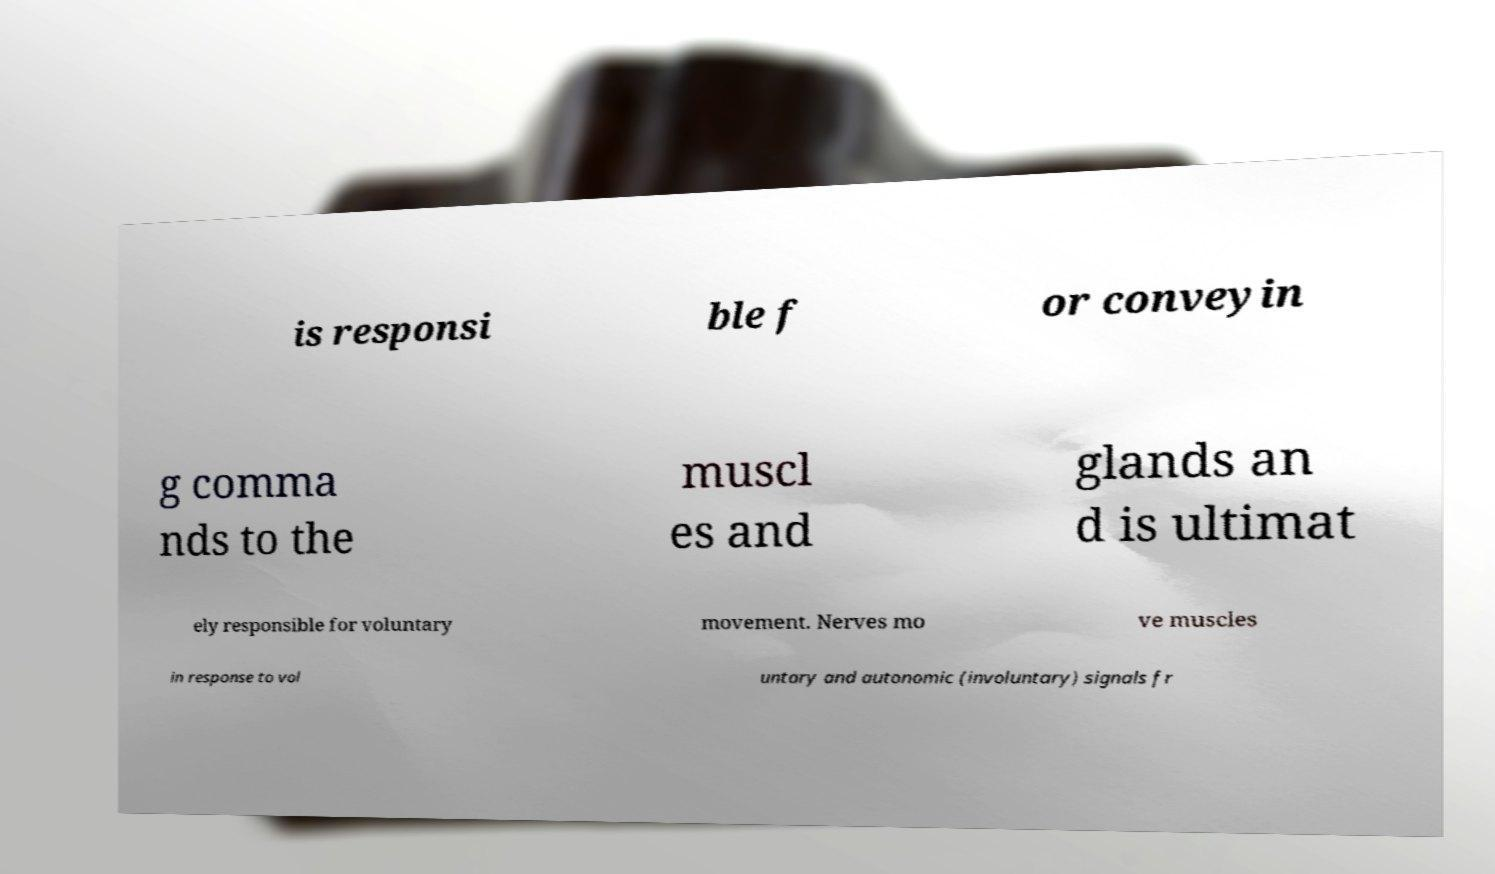Please identify and transcribe the text found in this image. is responsi ble f or conveyin g comma nds to the muscl es and glands an d is ultimat ely responsible for voluntary movement. Nerves mo ve muscles in response to vol untary and autonomic (involuntary) signals fr 